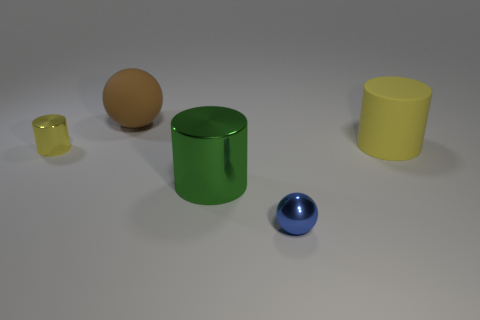There is a rubber thing that is in front of the large brown ball; how big is it?
Make the answer very short. Large. What number of other things are there of the same material as the large brown thing
Give a very brief answer. 1. There is a large thing right of the tiny blue metallic sphere; is there a shiny thing that is on the left side of it?
Give a very brief answer. Yes. There is a tiny shiny object that is the same shape as the brown matte thing; what is its color?
Make the answer very short. Blue. What is the size of the yellow metallic cylinder?
Offer a terse response. Small. Are there fewer big matte objects in front of the green metal thing than big red cylinders?
Provide a short and direct response. No. Does the large brown thing have the same material as the large cylinder that is on the right side of the small blue metal object?
Provide a short and direct response. Yes. Is there a tiny yellow thing that is on the left side of the sphere behind the yellow cylinder on the left side of the blue thing?
Provide a succinct answer. Yes. What is the color of the tiny thing that is the same material as the tiny blue ball?
Make the answer very short. Yellow. How big is the object that is both on the left side of the big green metallic object and in front of the big brown object?
Keep it short and to the point. Small. 